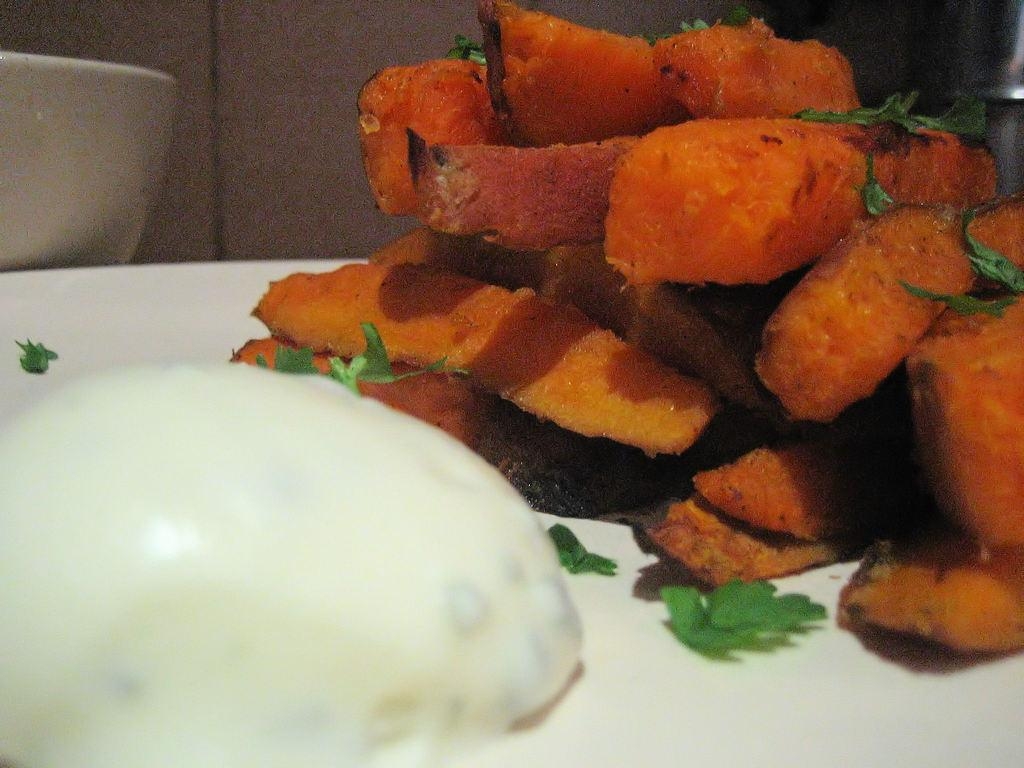What type of food can be seen in the image? There are french fries in the image. What is sprinkled on top of the food? Chopped coriander leaves are present in the image. What else is on the plate with the french fries? There is another food item on the plate. How is the plate shaped? The plate resembles a bowl. What type of insect can be seen crawling on the french fries in the image? There are no insects present in the image; it only shows french fries, chopped coriander leaves, and another food item on a plate that resembles a bowl. 